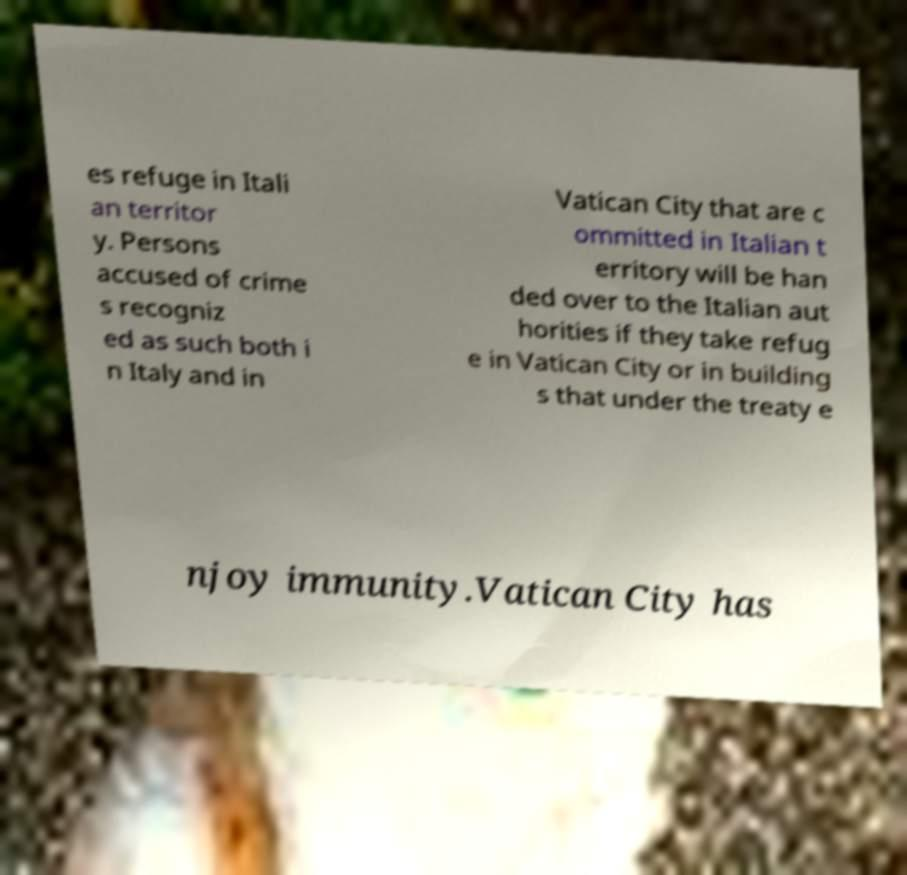Please read and relay the text visible in this image. What does it say? es refuge in Itali an territor y. Persons accused of crime s recogniz ed as such both i n Italy and in Vatican City that are c ommitted in Italian t erritory will be han ded over to the Italian aut horities if they take refug e in Vatican City or in building s that under the treaty e njoy immunity.Vatican City has 